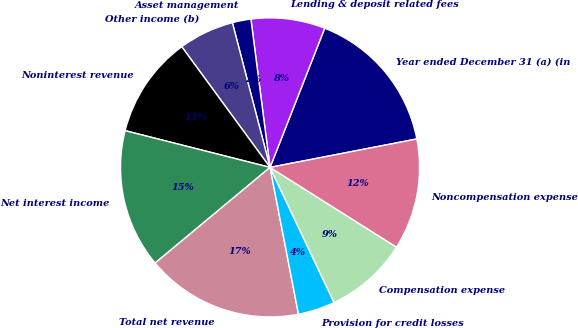Convert chart to OTSL. <chart><loc_0><loc_0><loc_500><loc_500><pie_chart><fcel>Year ended December 31 (a) (in<fcel>Lending & deposit related fees<fcel>Asset management<fcel>Other income (b)<fcel>Noninterest revenue<fcel>Net interest income<fcel>Total net revenue<fcel>Provision for credit losses<fcel>Compensation expense<fcel>Noncompensation expense<nl><fcel>16.0%<fcel>8.0%<fcel>2.01%<fcel>6.0%<fcel>11.0%<fcel>15.0%<fcel>17.0%<fcel>4.0%<fcel>9.0%<fcel>12.0%<nl></chart> 